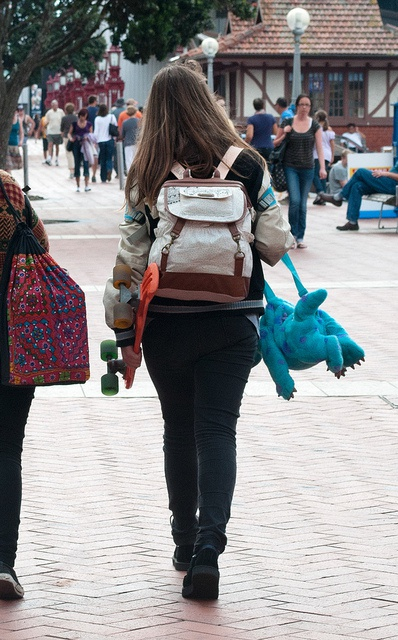Describe the objects in this image and their specific colors. I can see people in black, gray, darkgray, and maroon tones, backpack in black, darkgray, lightgray, and gray tones, backpack in black, maroon, purple, and navy tones, handbag in black, teal, and lightgray tones, and people in black, blue, darkblue, and lightpink tones in this image. 